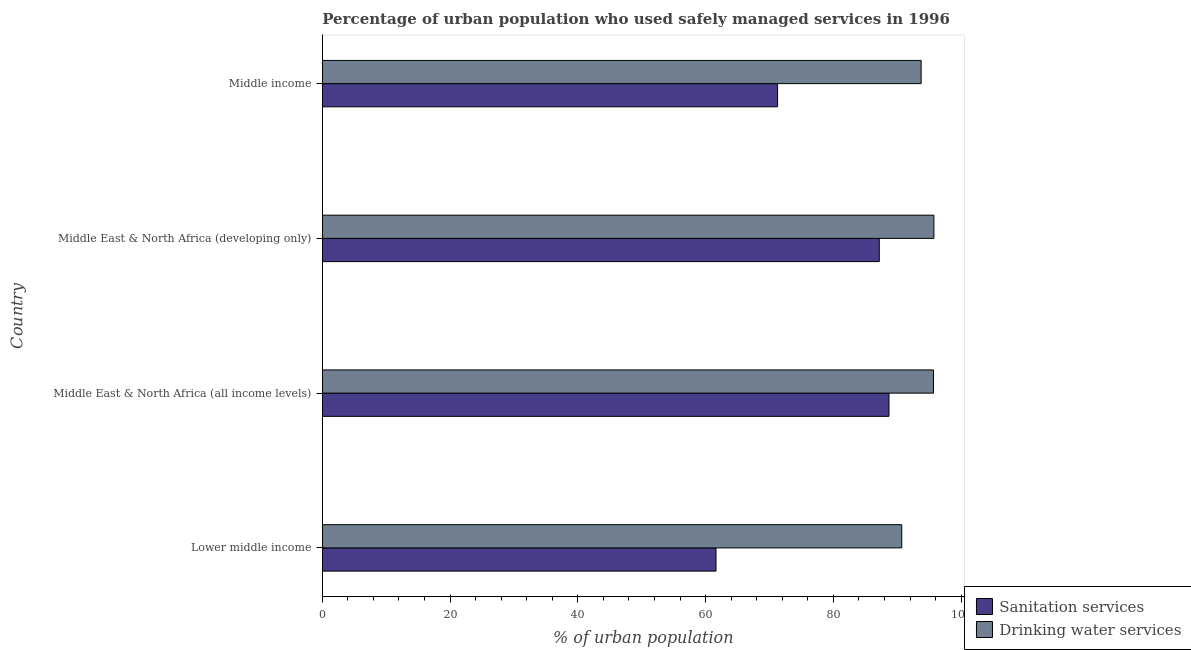Are the number of bars on each tick of the Y-axis equal?
Your response must be concise. Yes. How many bars are there on the 3rd tick from the top?
Offer a very short reply. 2. How many bars are there on the 3rd tick from the bottom?
Your response must be concise. 2. What is the label of the 1st group of bars from the top?
Give a very brief answer. Middle income. What is the percentage of urban population who used drinking water services in Middle East & North Africa (all income levels)?
Provide a short and direct response. 95.67. Across all countries, what is the maximum percentage of urban population who used sanitation services?
Give a very brief answer. 88.71. Across all countries, what is the minimum percentage of urban population who used sanitation services?
Offer a terse response. 61.62. In which country was the percentage of urban population who used sanitation services maximum?
Offer a terse response. Middle East & North Africa (all income levels). In which country was the percentage of urban population who used sanitation services minimum?
Make the answer very short. Lower middle income. What is the total percentage of urban population who used drinking water services in the graph?
Provide a succinct answer. 375.85. What is the difference between the percentage of urban population who used drinking water services in Lower middle income and that in Middle East & North Africa (all income levels)?
Give a very brief answer. -4.97. What is the difference between the percentage of urban population who used drinking water services in Middle income and the percentage of urban population who used sanitation services in Middle East & North Africa (all income levels)?
Offer a very short reply. 5.03. What is the average percentage of urban population who used sanitation services per country?
Your answer should be compact. 77.2. What is the difference between the percentage of urban population who used drinking water services and percentage of urban population who used sanitation services in Lower middle income?
Provide a succinct answer. 29.08. What is the ratio of the percentage of urban population who used sanitation services in Lower middle income to that in Middle East & North Africa (developing only)?
Provide a short and direct response. 0.71. What is the difference between the highest and the second highest percentage of urban population who used drinking water services?
Make the answer very short. 0.06. What is the difference between the highest and the lowest percentage of urban population who used drinking water services?
Provide a succinct answer. 5.03. Is the sum of the percentage of urban population who used drinking water services in Middle East & North Africa (all income levels) and Middle East & North Africa (developing only) greater than the maximum percentage of urban population who used sanitation services across all countries?
Make the answer very short. Yes. What does the 2nd bar from the top in Middle East & North Africa (all income levels) represents?
Provide a succinct answer. Sanitation services. What does the 1st bar from the bottom in Lower middle income represents?
Provide a short and direct response. Sanitation services. Are all the bars in the graph horizontal?
Your response must be concise. Yes. Are the values on the major ticks of X-axis written in scientific E-notation?
Your answer should be very brief. No. Does the graph contain grids?
Give a very brief answer. No. How are the legend labels stacked?
Make the answer very short. Vertical. What is the title of the graph?
Offer a very short reply. Percentage of urban population who used safely managed services in 1996. Does "Primary" appear as one of the legend labels in the graph?
Keep it short and to the point. No. What is the label or title of the X-axis?
Keep it short and to the point. % of urban population. What is the % of urban population of Sanitation services in Lower middle income?
Give a very brief answer. 61.62. What is the % of urban population of Drinking water services in Lower middle income?
Ensure brevity in your answer.  90.7. What is the % of urban population of Sanitation services in Middle East & North Africa (all income levels)?
Your answer should be very brief. 88.71. What is the % of urban population of Drinking water services in Middle East & North Africa (all income levels)?
Provide a short and direct response. 95.67. What is the % of urban population of Sanitation services in Middle East & North Africa (developing only)?
Your response must be concise. 87.19. What is the % of urban population in Drinking water services in Middle East & North Africa (developing only)?
Your answer should be very brief. 95.73. What is the % of urban population in Sanitation services in Middle income?
Offer a terse response. 71.27. What is the % of urban population in Drinking water services in Middle income?
Offer a terse response. 93.74. Across all countries, what is the maximum % of urban population in Sanitation services?
Your response must be concise. 88.71. Across all countries, what is the maximum % of urban population in Drinking water services?
Give a very brief answer. 95.73. Across all countries, what is the minimum % of urban population of Sanitation services?
Ensure brevity in your answer.  61.62. Across all countries, what is the minimum % of urban population in Drinking water services?
Provide a short and direct response. 90.7. What is the total % of urban population in Sanitation services in the graph?
Your answer should be compact. 308.78. What is the total % of urban population of Drinking water services in the graph?
Your response must be concise. 375.85. What is the difference between the % of urban population of Sanitation services in Lower middle income and that in Middle East & North Africa (all income levels)?
Your answer should be very brief. -27.08. What is the difference between the % of urban population in Drinking water services in Lower middle income and that in Middle East & North Africa (all income levels)?
Your response must be concise. -4.97. What is the difference between the % of urban population in Sanitation services in Lower middle income and that in Middle East & North Africa (developing only)?
Provide a short and direct response. -25.56. What is the difference between the % of urban population of Drinking water services in Lower middle income and that in Middle East & North Africa (developing only)?
Provide a short and direct response. -5.03. What is the difference between the % of urban population of Sanitation services in Lower middle income and that in Middle income?
Your answer should be very brief. -9.64. What is the difference between the % of urban population of Drinking water services in Lower middle income and that in Middle income?
Ensure brevity in your answer.  -3.03. What is the difference between the % of urban population of Sanitation services in Middle East & North Africa (all income levels) and that in Middle East & North Africa (developing only)?
Your answer should be compact. 1.52. What is the difference between the % of urban population of Drinking water services in Middle East & North Africa (all income levels) and that in Middle East & North Africa (developing only)?
Your answer should be very brief. -0.06. What is the difference between the % of urban population of Sanitation services in Middle East & North Africa (all income levels) and that in Middle income?
Give a very brief answer. 17.44. What is the difference between the % of urban population of Drinking water services in Middle East & North Africa (all income levels) and that in Middle income?
Your response must be concise. 1.93. What is the difference between the % of urban population in Sanitation services in Middle East & North Africa (developing only) and that in Middle income?
Your answer should be very brief. 15.92. What is the difference between the % of urban population in Drinking water services in Middle East & North Africa (developing only) and that in Middle income?
Make the answer very short. 2. What is the difference between the % of urban population of Sanitation services in Lower middle income and the % of urban population of Drinking water services in Middle East & North Africa (all income levels)?
Make the answer very short. -34.05. What is the difference between the % of urban population of Sanitation services in Lower middle income and the % of urban population of Drinking water services in Middle East & North Africa (developing only)?
Ensure brevity in your answer.  -34.11. What is the difference between the % of urban population in Sanitation services in Lower middle income and the % of urban population in Drinking water services in Middle income?
Provide a short and direct response. -32.11. What is the difference between the % of urban population of Sanitation services in Middle East & North Africa (all income levels) and the % of urban population of Drinking water services in Middle East & North Africa (developing only)?
Ensure brevity in your answer.  -7.03. What is the difference between the % of urban population of Sanitation services in Middle East & North Africa (all income levels) and the % of urban population of Drinking water services in Middle income?
Offer a terse response. -5.03. What is the difference between the % of urban population in Sanitation services in Middle East & North Africa (developing only) and the % of urban population in Drinking water services in Middle income?
Offer a very short reply. -6.55. What is the average % of urban population of Sanitation services per country?
Your answer should be compact. 77.2. What is the average % of urban population in Drinking water services per country?
Give a very brief answer. 93.96. What is the difference between the % of urban population of Sanitation services and % of urban population of Drinking water services in Lower middle income?
Your answer should be compact. -29.08. What is the difference between the % of urban population in Sanitation services and % of urban population in Drinking water services in Middle East & North Africa (all income levels)?
Offer a terse response. -6.96. What is the difference between the % of urban population of Sanitation services and % of urban population of Drinking water services in Middle East & North Africa (developing only)?
Keep it short and to the point. -8.55. What is the difference between the % of urban population of Sanitation services and % of urban population of Drinking water services in Middle income?
Make the answer very short. -22.47. What is the ratio of the % of urban population of Sanitation services in Lower middle income to that in Middle East & North Africa (all income levels)?
Provide a succinct answer. 0.69. What is the ratio of the % of urban population of Drinking water services in Lower middle income to that in Middle East & North Africa (all income levels)?
Offer a terse response. 0.95. What is the ratio of the % of urban population of Sanitation services in Lower middle income to that in Middle East & North Africa (developing only)?
Provide a succinct answer. 0.71. What is the ratio of the % of urban population in Drinking water services in Lower middle income to that in Middle East & North Africa (developing only)?
Provide a short and direct response. 0.95. What is the ratio of the % of urban population in Sanitation services in Lower middle income to that in Middle income?
Offer a very short reply. 0.86. What is the ratio of the % of urban population in Drinking water services in Lower middle income to that in Middle income?
Provide a succinct answer. 0.97. What is the ratio of the % of urban population in Sanitation services in Middle East & North Africa (all income levels) to that in Middle East & North Africa (developing only)?
Your response must be concise. 1.02. What is the ratio of the % of urban population of Drinking water services in Middle East & North Africa (all income levels) to that in Middle East & North Africa (developing only)?
Offer a very short reply. 1. What is the ratio of the % of urban population of Sanitation services in Middle East & North Africa (all income levels) to that in Middle income?
Make the answer very short. 1.24. What is the ratio of the % of urban population of Drinking water services in Middle East & North Africa (all income levels) to that in Middle income?
Offer a terse response. 1.02. What is the ratio of the % of urban population of Sanitation services in Middle East & North Africa (developing only) to that in Middle income?
Offer a very short reply. 1.22. What is the ratio of the % of urban population in Drinking water services in Middle East & North Africa (developing only) to that in Middle income?
Offer a terse response. 1.02. What is the difference between the highest and the second highest % of urban population in Sanitation services?
Offer a terse response. 1.52. What is the difference between the highest and the second highest % of urban population of Drinking water services?
Ensure brevity in your answer.  0.06. What is the difference between the highest and the lowest % of urban population in Sanitation services?
Offer a terse response. 27.08. What is the difference between the highest and the lowest % of urban population of Drinking water services?
Keep it short and to the point. 5.03. 